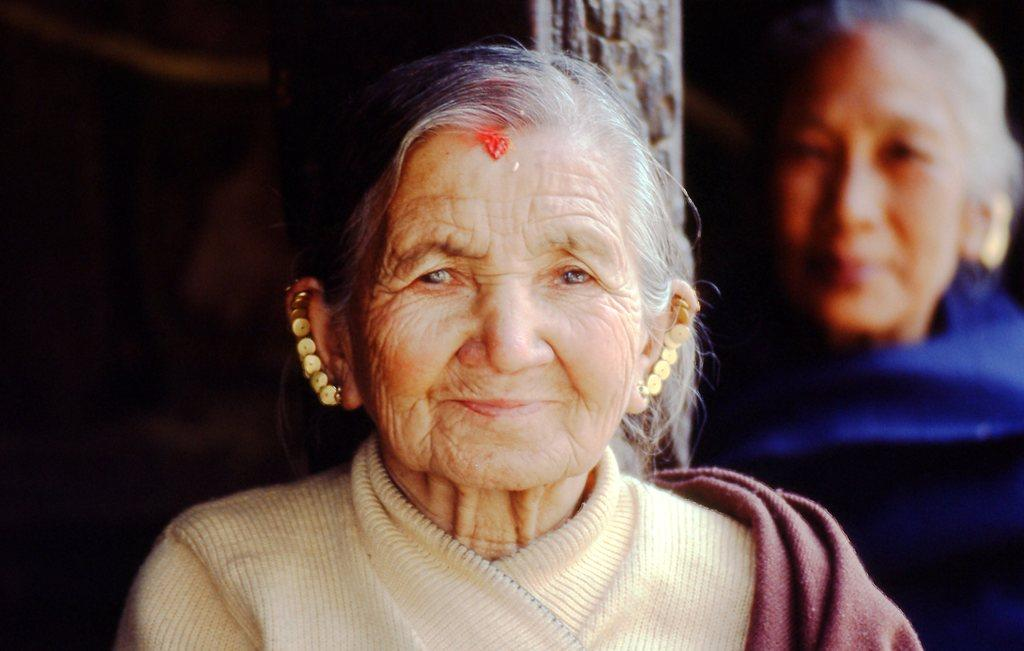Who or what can be seen in the image? There are people in the image. What architectural feature is present in the image? There is a pillar in the image. What type of instrument is being played by the people in the image? There is no instrument being played by the people in the image. Can you describe the recess in the image? There is no recess present in the image. How many beans are visible in the image? There are no beans visible in the image. 